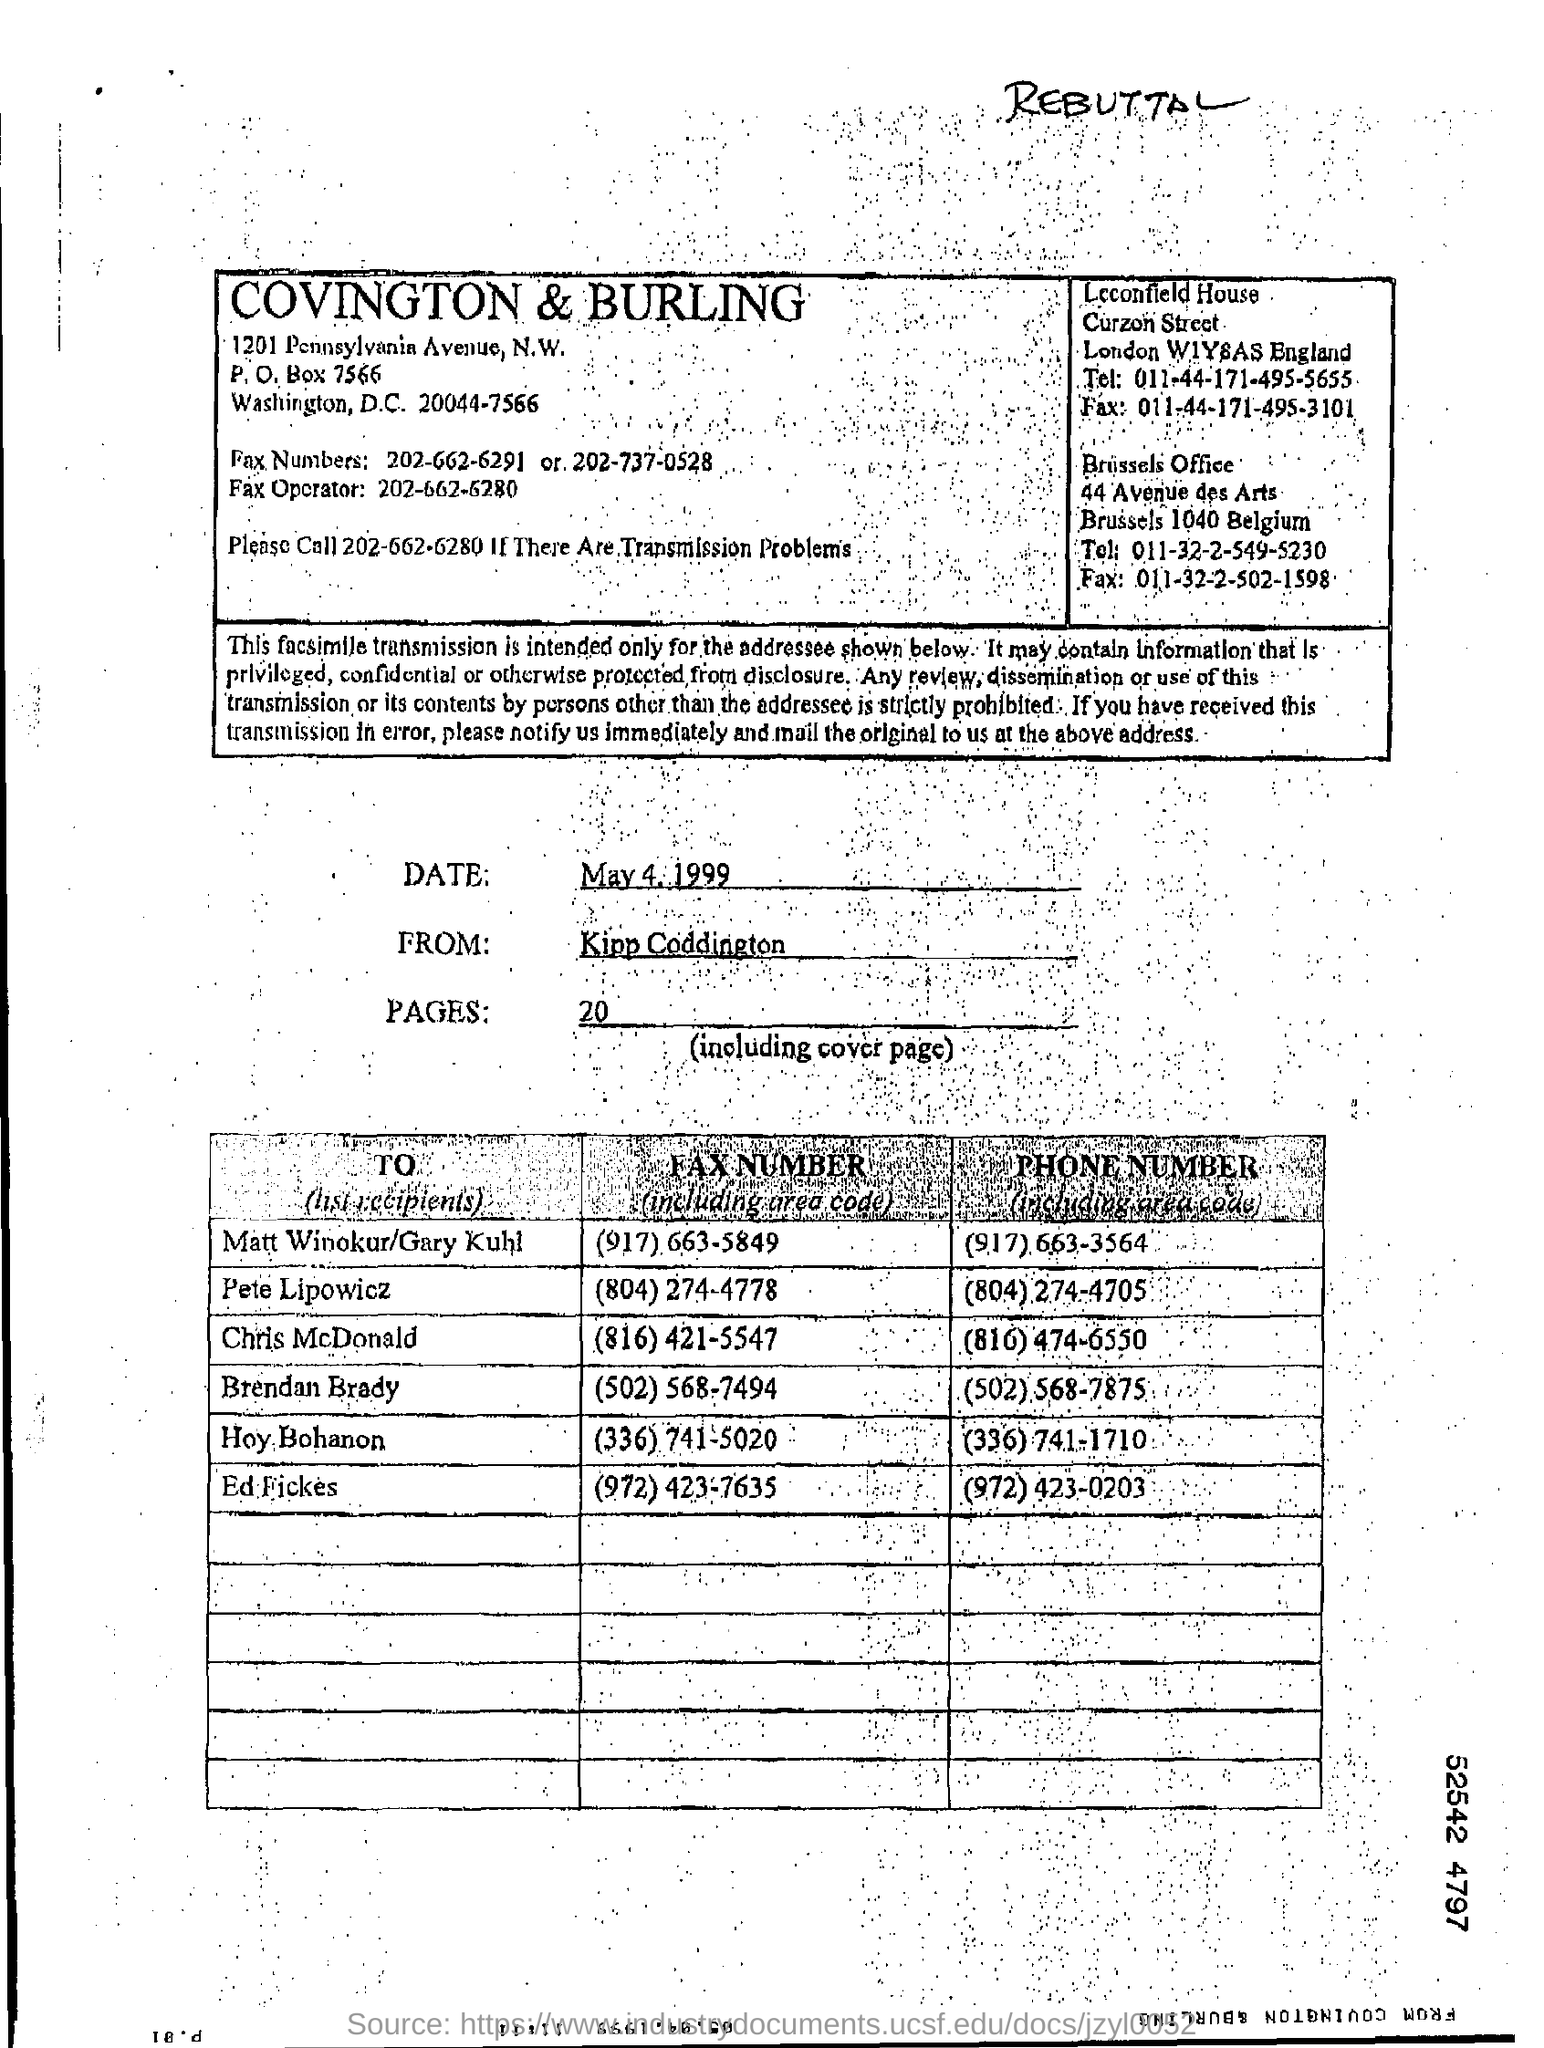Identify some key points in this picture. The phone number of Chris McDonald is (816) 474-6550. The date of the fax transmission is May 4, 1999. The number of pages in the fax, including the cover page, is 20. The sender of the fax is Kipp Coddington. The fax number of Ed Fickes is (972) 423-7635. 